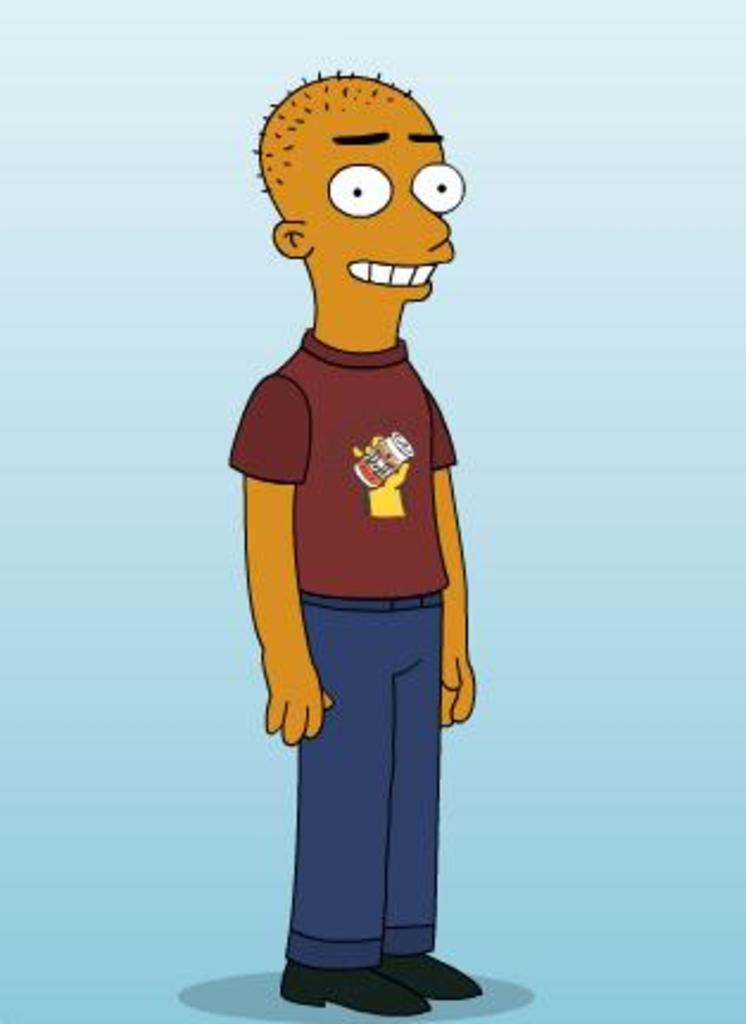How would you summarize this image in a sentence or two? In this image we can see one cartoon man standing and there is a white and sky blue color background. 